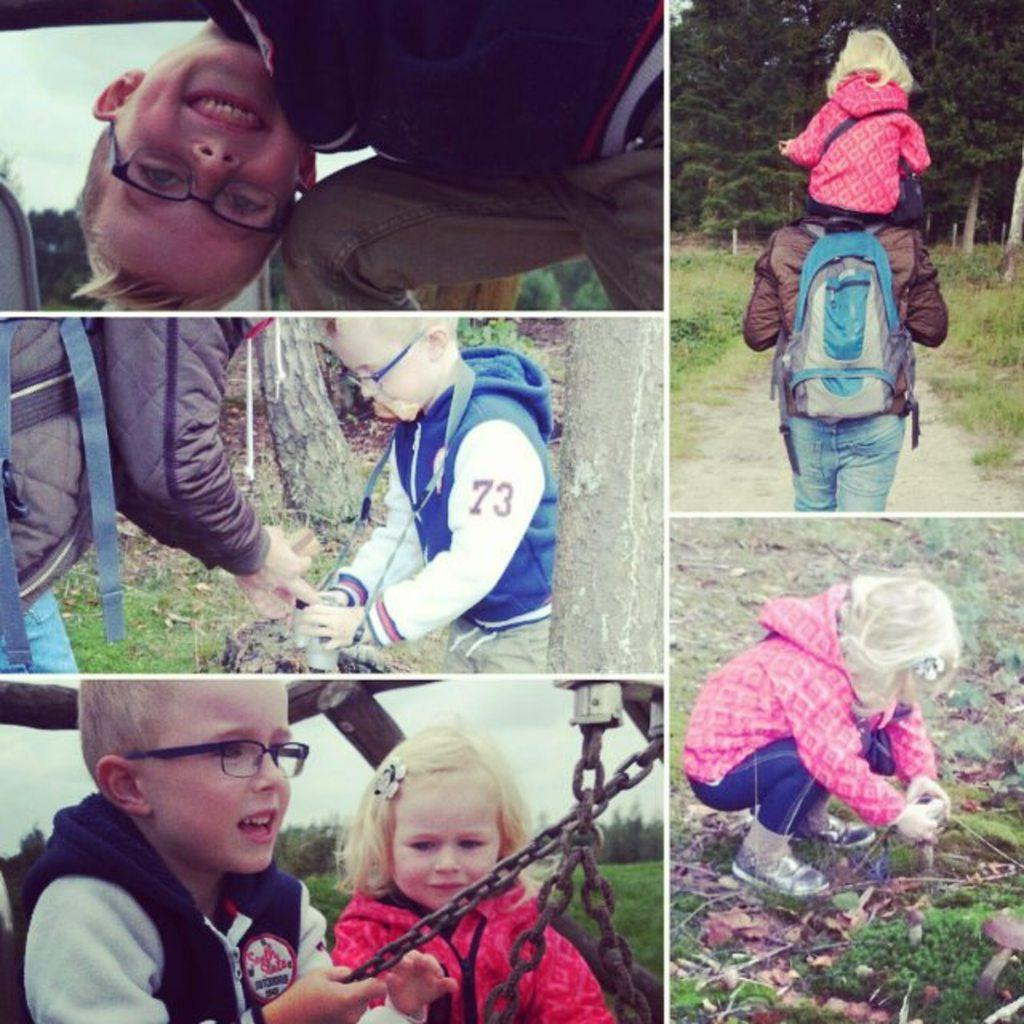What type of artwork is the image? The image is a collage. What can be seen in the collage? There are people, grass, trees, chains, and the sky visible in the image. Can you describe the natural elements in the collage? There is grass and trees visible in the image. What is the background of the collage? The sky is visible in the image. Where is the nest located in the image? There is no nest present in the image. How much sugar is visible in the image? There is no sugar visible in the image. 